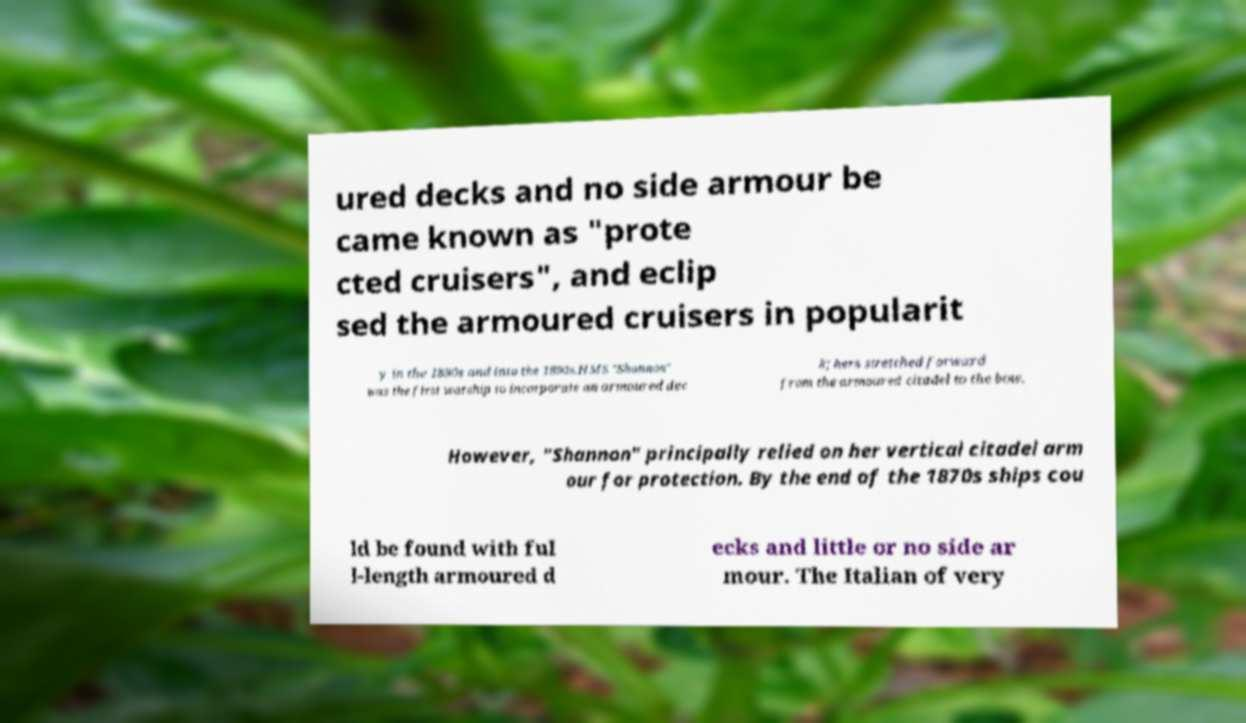Could you extract and type out the text from this image? ured decks and no side armour be came known as "prote cted cruisers", and eclip sed the armoured cruisers in popularit y in the 1880s and into the 1890s.HMS "Shannon" was the first warship to incorporate an armoured dec k; hers stretched forward from the armoured citadel to the bow. However, "Shannon" principally relied on her vertical citadel arm our for protection. By the end of the 1870s ships cou ld be found with ful l-length armoured d ecks and little or no side ar mour. The Italian of very 